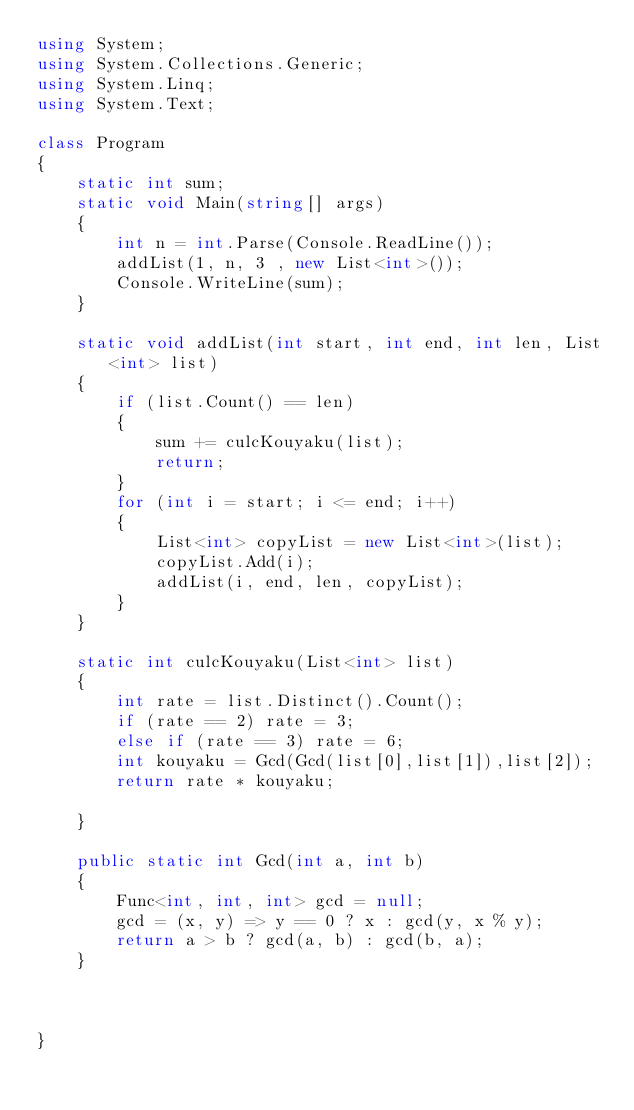<code> <loc_0><loc_0><loc_500><loc_500><_C#_>using System;
using System.Collections.Generic;
using System.Linq;
using System.Text;

class Program
{
    static int sum;
    static void Main(string[] args)
    {
        int n = int.Parse(Console.ReadLine());
        addList(1, n, 3 , new List<int>());
        Console.WriteLine(sum);
    }

    static void addList(int start, int end, int len, List<int> list)
    {
        if (list.Count() == len)
        {
            sum += culcKouyaku(list);
            return;
        }
        for (int i = start; i <= end; i++)
        {
            List<int> copyList = new List<int>(list);
            copyList.Add(i);
            addList(i, end, len, copyList);
        }
    }

    static int culcKouyaku(List<int> list)
    {
        int rate = list.Distinct().Count();
        if (rate == 2) rate = 3;
        else if (rate == 3) rate = 6;
        int kouyaku = Gcd(Gcd(list[0],list[1]),list[2]);
        return rate * kouyaku;

    }

    public static int Gcd(int a, int b)
    {
        Func<int, int, int> gcd = null;
        gcd = (x, y) => y == 0 ? x : gcd(y, x % y);
        return a > b ? gcd(a, b) : gcd(b, a);
    }



}

</code> 